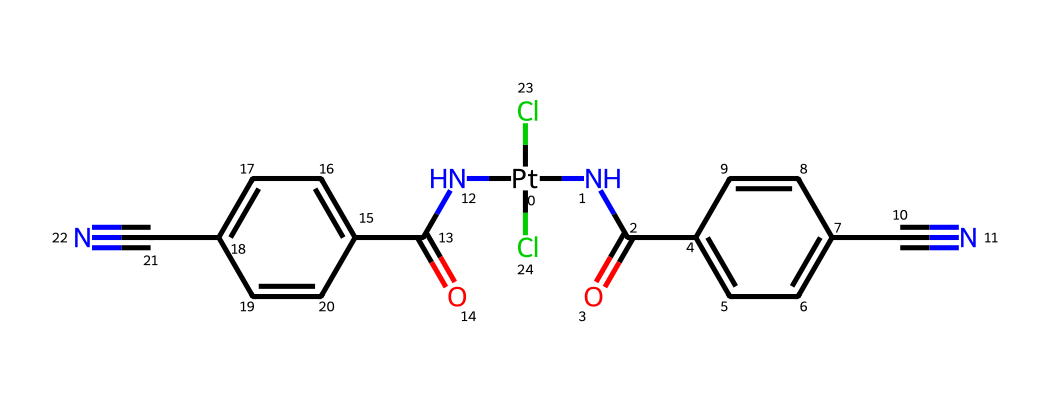how many platinum atoms are present in this compound? The chemical structure provided includes one platinum atom directly indicated by the [Pt] notation in the SMILES representation.
Answer: 1 what is the connectivity of the platinum atom in this compound? The platinum atom is connected to two nitrogen atoms through amide linkages (from the NC(=O) groups) and is also connected to two chlorine atoms. This suggests that platinum is in a coordination complex form, stabilized by these ligands.
Answer: amide and chloride what type of chemical reaction might this compound undergo in conductive textiles? Given that this compound is organometallic and contains platinum, it may undergo redox reactions that can enhance conductivity or catalytic activities when integrated into textiles.
Answer: redox how many nitrogen atoms are in this compound? On analyzing the SMILES representation, each of the two amide groups (NC(=O)) contains one nitrogen atom, totaling two nitrogen atoms present in the entire structure.
Answer: 2 what is the oxidation state of platinum in this compound? Typically, in complexes like this one with two chloride ligands and considering the charges on the amide groups, the oxidation state for platinum is likely +2.
Answer: +2 which functional groups are present in this compound? The SMILES structure indicates the presence of the amide groups (NC(=O)) and nitrile groups (C#N), which provide distinct functional characteristics to this compound.
Answer: amide and nitrile how does the presence of the chloro groups contribute to the functionality of this compound? Chlorine atoms often enhance the solubility of organometallic complexes and can influence the electronic properties of the platinum center, potentially enhancing its interactions within conductive textile applications.
Answer: enhances solubility and electronic properties 